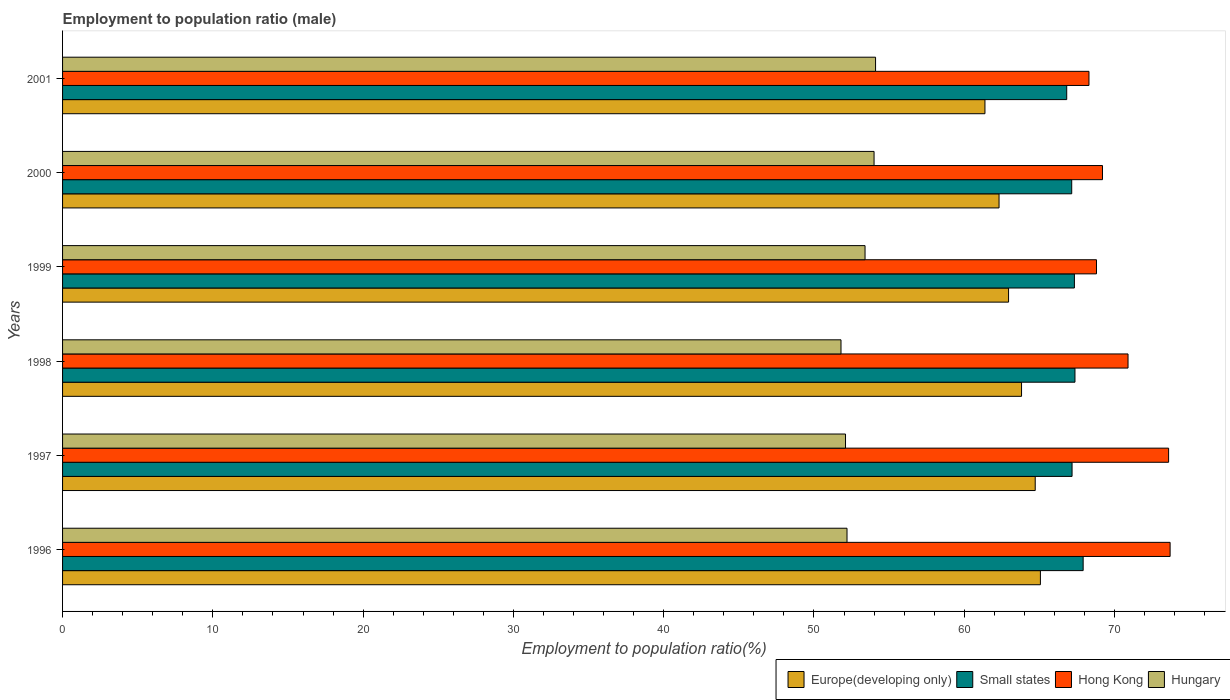How many different coloured bars are there?
Your answer should be very brief. 4. Are the number of bars per tick equal to the number of legend labels?
Offer a terse response. Yes. How many bars are there on the 6th tick from the bottom?
Offer a terse response. 4. What is the label of the 1st group of bars from the top?
Ensure brevity in your answer.  2001. In how many cases, is the number of bars for a given year not equal to the number of legend labels?
Offer a terse response. 0. What is the employment to population ratio in Hungary in 1998?
Offer a very short reply. 51.8. Across all years, what is the maximum employment to population ratio in Hungary?
Offer a terse response. 54.1. Across all years, what is the minimum employment to population ratio in Hong Kong?
Provide a short and direct response. 68.3. In which year was the employment to population ratio in Europe(developing only) maximum?
Keep it short and to the point. 1996. What is the total employment to population ratio in Small states in the graph?
Your answer should be compact. 403.76. What is the difference between the employment to population ratio in Small states in 1998 and that in 2000?
Keep it short and to the point. 0.22. What is the difference between the employment to population ratio in Hungary in 2000 and the employment to population ratio in Small states in 1998?
Your answer should be very brief. -13.37. What is the average employment to population ratio in Small states per year?
Offer a very short reply. 67.29. In the year 1998, what is the difference between the employment to population ratio in Small states and employment to population ratio in Europe(developing only)?
Keep it short and to the point. 3.56. In how many years, is the employment to population ratio in Hong Kong greater than 8 %?
Keep it short and to the point. 6. What is the ratio of the employment to population ratio in Small states in 2000 to that in 2001?
Ensure brevity in your answer.  1. What is the difference between the highest and the second highest employment to population ratio in Hungary?
Ensure brevity in your answer.  0.1. What is the difference between the highest and the lowest employment to population ratio in Hungary?
Your answer should be very brief. 2.3. Is the sum of the employment to population ratio in Hungary in 1996 and 1999 greater than the maximum employment to population ratio in Hong Kong across all years?
Provide a short and direct response. Yes. What does the 1st bar from the top in 2001 represents?
Keep it short and to the point. Hungary. What does the 2nd bar from the bottom in 2001 represents?
Your answer should be very brief. Small states. How many bars are there?
Provide a succinct answer. 24. Are all the bars in the graph horizontal?
Your response must be concise. Yes. What is the difference between two consecutive major ticks on the X-axis?
Your answer should be very brief. 10. Does the graph contain grids?
Keep it short and to the point. No. How many legend labels are there?
Offer a terse response. 4. How are the legend labels stacked?
Keep it short and to the point. Horizontal. What is the title of the graph?
Give a very brief answer. Employment to population ratio (male). What is the label or title of the Y-axis?
Offer a terse response. Years. What is the Employment to population ratio(%) in Europe(developing only) in 1996?
Make the answer very short. 65.07. What is the Employment to population ratio(%) of Small states in 1996?
Make the answer very short. 67.91. What is the Employment to population ratio(%) of Hong Kong in 1996?
Make the answer very short. 73.7. What is the Employment to population ratio(%) of Hungary in 1996?
Your answer should be compact. 52.2. What is the Employment to population ratio(%) in Europe(developing only) in 1997?
Provide a succinct answer. 64.72. What is the Employment to population ratio(%) in Small states in 1997?
Keep it short and to the point. 67.17. What is the Employment to population ratio(%) in Hong Kong in 1997?
Provide a short and direct response. 73.6. What is the Employment to population ratio(%) of Hungary in 1997?
Your answer should be compact. 52.1. What is the Employment to population ratio(%) of Europe(developing only) in 1998?
Ensure brevity in your answer.  63.81. What is the Employment to population ratio(%) of Small states in 1998?
Ensure brevity in your answer.  67.37. What is the Employment to population ratio(%) in Hong Kong in 1998?
Your answer should be compact. 70.9. What is the Employment to population ratio(%) of Hungary in 1998?
Keep it short and to the point. 51.8. What is the Employment to population ratio(%) of Europe(developing only) in 1999?
Your answer should be very brief. 62.95. What is the Employment to population ratio(%) of Small states in 1999?
Make the answer very short. 67.33. What is the Employment to population ratio(%) of Hong Kong in 1999?
Ensure brevity in your answer.  68.8. What is the Employment to population ratio(%) in Hungary in 1999?
Your response must be concise. 53.4. What is the Employment to population ratio(%) in Europe(developing only) in 2000?
Your response must be concise. 62.32. What is the Employment to population ratio(%) in Small states in 2000?
Your answer should be very brief. 67.15. What is the Employment to population ratio(%) in Hong Kong in 2000?
Make the answer very short. 69.2. What is the Employment to population ratio(%) of Hungary in 2000?
Ensure brevity in your answer.  54. What is the Employment to population ratio(%) in Europe(developing only) in 2001?
Provide a succinct answer. 61.38. What is the Employment to population ratio(%) in Small states in 2001?
Ensure brevity in your answer.  66.82. What is the Employment to population ratio(%) in Hong Kong in 2001?
Ensure brevity in your answer.  68.3. What is the Employment to population ratio(%) in Hungary in 2001?
Provide a short and direct response. 54.1. Across all years, what is the maximum Employment to population ratio(%) of Europe(developing only)?
Offer a very short reply. 65.07. Across all years, what is the maximum Employment to population ratio(%) in Small states?
Ensure brevity in your answer.  67.91. Across all years, what is the maximum Employment to population ratio(%) in Hong Kong?
Your response must be concise. 73.7. Across all years, what is the maximum Employment to population ratio(%) of Hungary?
Your answer should be compact. 54.1. Across all years, what is the minimum Employment to population ratio(%) in Europe(developing only)?
Keep it short and to the point. 61.38. Across all years, what is the minimum Employment to population ratio(%) of Small states?
Ensure brevity in your answer.  66.82. Across all years, what is the minimum Employment to population ratio(%) in Hong Kong?
Offer a very short reply. 68.3. Across all years, what is the minimum Employment to population ratio(%) in Hungary?
Give a very brief answer. 51.8. What is the total Employment to population ratio(%) in Europe(developing only) in the graph?
Ensure brevity in your answer.  380.25. What is the total Employment to population ratio(%) in Small states in the graph?
Provide a short and direct response. 403.76. What is the total Employment to population ratio(%) in Hong Kong in the graph?
Make the answer very short. 424.5. What is the total Employment to population ratio(%) in Hungary in the graph?
Offer a terse response. 317.6. What is the difference between the Employment to population ratio(%) of Europe(developing only) in 1996 and that in 1997?
Provide a succinct answer. 0.35. What is the difference between the Employment to population ratio(%) in Small states in 1996 and that in 1997?
Your answer should be compact. 0.74. What is the difference between the Employment to population ratio(%) of Europe(developing only) in 1996 and that in 1998?
Offer a terse response. 1.26. What is the difference between the Employment to population ratio(%) of Small states in 1996 and that in 1998?
Keep it short and to the point. 0.54. What is the difference between the Employment to population ratio(%) of Hungary in 1996 and that in 1998?
Give a very brief answer. 0.4. What is the difference between the Employment to population ratio(%) of Europe(developing only) in 1996 and that in 1999?
Keep it short and to the point. 2.12. What is the difference between the Employment to population ratio(%) in Small states in 1996 and that in 1999?
Offer a terse response. 0.58. What is the difference between the Employment to population ratio(%) in Europe(developing only) in 1996 and that in 2000?
Offer a very short reply. 2.75. What is the difference between the Employment to population ratio(%) in Small states in 1996 and that in 2000?
Make the answer very short. 0.76. What is the difference between the Employment to population ratio(%) in Hong Kong in 1996 and that in 2000?
Your answer should be very brief. 4.5. What is the difference between the Employment to population ratio(%) in Hungary in 1996 and that in 2000?
Your answer should be very brief. -1.8. What is the difference between the Employment to population ratio(%) of Europe(developing only) in 1996 and that in 2001?
Offer a very short reply. 3.69. What is the difference between the Employment to population ratio(%) in Small states in 1996 and that in 2001?
Offer a very short reply. 1.09. What is the difference between the Employment to population ratio(%) of Europe(developing only) in 1997 and that in 1998?
Provide a succinct answer. 0.91. What is the difference between the Employment to population ratio(%) in Small states in 1997 and that in 1998?
Provide a succinct answer. -0.19. What is the difference between the Employment to population ratio(%) in Hong Kong in 1997 and that in 1998?
Keep it short and to the point. 2.7. What is the difference between the Employment to population ratio(%) of Hungary in 1997 and that in 1998?
Give a very brief answer. 0.3. What is the difference between the Employment to population ratio(%) of Europe(developing only) in 1997 and that in 1999?
Offer a very short reply. 1.77. What is the difference between the Employment to population ratio(%) in Small states in 1997 and that in 1999?
Provide a short and direct response. -0.16. What is the difference between the Employment to population ratio(%) of Hungary in 1997 and that in 1999?
Ensure brevity in your answer.  -1.3. What is the difference between the Employment to population ratio(%) of Europe(developing only) in 1997 and that in 2000?
Your response must be concise. 2.41. What is the difference between the Employment to population ratio(%) in Small states in 1997 and that in 2000?
Provide a short and direct response. 0.02. What is the difference between the Employment to population ratio(%) in Hungary in 1997 and that in 2000?
Ensure brevity in your answer.  -1.9. What is the difference between the Employment to population ratio(%) in Europe(developing only) in 1997 and that in 2001?
Keep it short and to the point. 3.34. What is the difference between the Employment to population ratio(%) in Small states in 1997 and that in 2001?
Provide a short and direct response. 0.36. What is the difference between the Employment to population ratio(%) in Hong Kong in 1997 and that in 2001?
Ensure brevity in your answer.  5.3. What is the difference between the Employment to population ratio(%) in Europe(developing only) in 1998 and that in 1999?
Make the answer very short. 0.86. What is the difference between the Employment to population ratio(%) in Small states in 1998 and that in 1999?
Give a very brief answer. 0.04. What is the difference between the Employment to population ratio(%) of Hong Kong in 1998 and that in 1999?
Ensure brevity in your answer.  2.1. What is the difference between the Employment to population ratio(%) in Europe(developing only) in 1998 and that in 2000?
Your answer should be very brief. 1.5. What is the difference between the Employment to population ratio(%) in Small states in 1998 and that in 2000?
Your response must be concise. 0.22. What is the difference between the Employment to population ratio(%) in Hong Kong in 1998 and that in 2000?
Ensure brevity in your answer.  1.7. What is the difference between the Employment to population ratio(%) in Europe(developing only) in 1998 and that in 2001?
Your answer should be compact. 2.43. What is the difference between the Employment to population ratio(%) in Small states in 1998 and that in 2001?
Your response must be concise. 0.55. What is the difference between the Employment to population ratio(%) of Hong Kong in 1998 and that in 2001?
Your response must be concise. 2.6. What is the difference between the Employment to population ratio(%) of Hungary in 1998 and that in 2001?
Your answer should be very brief. -2.3. What is the difference between the Employment to population ratio(%) of Europe(developing only) in 1999 and that in 2000?
Keep it short and to the point. 0.63. What is the difference between the Employment to population ratio(%) of Small states in 1999 and that in 2000?
Keep it short and to the point. 0.18. What is the difference between the Employment to population ratio(%) in Hong Kong in 1999 and that in 2000?
Your answer should be very brief. -0.4. What is the difference between the Employment to population ratio(%) of Hungary in 1999 and that in 2000?
Your response must be concise. -0.6. What is the difference between the Employment to population ratio(%) in Europe(developing only) in 1999 and that in 2001?
Provide a short and direct response. 1.57. What is the difference between the Employment to population ratio(%) in Small states in 1999 and that in 2001?
Provide a succinct answer. 0.51. What is the difference between the Employment to population ratio(%) of Hong Kong in 1999 and that in 2001?
Give a very brief answer. 0.5. What is the difference between the Employment to population ratio(%) in Europe(developing only) in 2000 and that in 2001?
Your response must be concise. 0.94. What is the difference between the Employment to population ratio(%) of Small states in 2000 and that in 2001?
Provide a short and direct response. 0.33. What is the difference between the Employment to population ratio(%) in Hungary in 2000 and that in 2001?
Your answer should be compact. -0.1. What is the difference between the Employment to population ratio(%) in Europe(developing only) in 1996 and the Employment to population ratio(%) in Small states in 1997?
Make the answer very short. -2.11. What is the difference between the Employment to population ratio(%) in Europe(developing only) in 1996 and the Employment to population ratio(%) in Hong Kong in 1997?
Give a very brief answer. -8.53. What is the difference between the Employment to population ratio(%) in Europe(developing only) in 1996 and the Employment to population ratio(%) in Hungary in 1997?
Give a very brief answer. 12.97. What is the difference between the Employment to population ratio(%) in Small states in 1996 and the Employment to population ratio(%) in Hong Kong in 1997?
Provide a succinct answer. -5.69. What is the difference between the Employment to population ratio(%) in Small states in 1996 and the Employment to population ratio(%) in Hungary in 1997?
Offer a very short reply. 15.81. What is the difference between the Employment to population ratio(%) in Hong Kong in 1996 and the Employment to population ratio(%) in Hungary in 1997?
Keep it short and to the point. 21.6. What is the difference between the Employment to population ratio(%) of Europe(developing only) in 1996 and the Employment to population ratio(%) of Small states in 1998?
Offer a terse response. -2.3. What is the difference between the Employment to population ratio(%) in Europe(developing only) in 1996 and the Employment to population ratio(%) in Hong Kong in 1998?
Keep it short and to the point. -5.83. What is the difference between the Employment to population ratio(%) of Europe(developing only) in 1996 and the Employment to population ratio(%) of Hungary in 1998?
Provide a succinct answer. 13.27. What is the difference between the Employment to population ratio(%) in Small states in 1996 and the Employment to population ratio(%) in Hong Kong in 1998?
Your response must be concise. -2.99. What is the difference between the Employment to population ratio(%) of Small states in 1996 and the Employment to population ratio(%) of Hungary in 1998?
Provide a short and direct response. 16.11. What is the difference between the Employment to population ratio(%) of Hong Kong in 1996 and the Employment to population ratio(%) of Hungary in 1998?
Offer a very short reply. 21.9. What is the difference between the Employment to population ratio(%) of Europe(developing only) in 1996 and the Employment to population ratio(%) of Small states in 1999?
Keep it short and to the point. -2.26. What is the difference between the Employment to population ratio(%) of Europe(developing only) in 1996 and the Employment to population ratio(%) of Hong Kong in 1999?
Provide a succinct answer. -3.73. What is the difference between the Employment to population ratio(%) of Europe(developing only) in 1996 and the Employment to population ratio(%) of Hungary in 1999?
Offer a very short reply. 11.67. What is the difference between the Employment to population ratio(%) in Small states in 1996 and the Employment to population ratio(%) in Hong Kong in 1999?
Your answer should be compact. -0.89. What is the difference between the Employment to population ratio(%) of Small states in 1996 and the Employment to population ratio(%) of Hungary in 1999?
Make the answer very short. 14.51. What is the difference between the Employment to population ratio(%) of Hong Kong in 1996 and the Employment to population ratio(%) of Hungary in 1999?
Give a very brief answer. 20.3. What is the difference between the Employment to population ratio(%) of Europe(developing only) in 1996 and the Employment to population ratio(%) of Small states in 2000?
Give a very brief answer. -2.08. What is the difference between the Employment to population ratio(%) in Europe(developing only) in 1996 and the Employment to population ratio(%) in Hong Kong in 2000?
Your response must be concise. -4.13. What is the difference between the Employment to population ratio(%) of Europe(developing only) in 1996 and the Employment to population ratio(%) of Hungary in 2000?
Give a very brief answer. 11.07. What is the difference between the Employment to population ratio(%) in Small states in 1996 and the Employment to population ratio(%) in Hong Kong in 2000?
Provide a succinct answer. -1.29. What is the difference between the Employment to population ratio(%) in Small states in 1996 and the Employment to population ratio(%) in Hungary in 2000?
Make the answer very short. 13.91. What is the difference between the Employment to population ratio(%) of Hong Kong in 1996 and the Employment to population ratio(%) of Hungary in 2000?
Offer a very short reply. 19.7. What is the difference between the Employment to population ratio(%) in Europe(developing only) in 1996 and the Employment to population ratio(%) in Small states in 2001?
Offer a terse response. -1.75. What is the difference between the Employment to population ratio(%) in Europe(developing only) in 1996 and the Employment to population ratio(%) in Hong Kong in 2001?
Give a very brief answer. -3.23. What is the difference between the Employment to population ratio(%) of Europe(developing only) in 1996 and the Employment to population ratio(%) of Hungary in 2001?
Your response must be concise. 10.97. What is the difference between the Employment to population ratio(%) of Small states in 1996 and the Employment to population ratio(%) of Hong Kong in 2001?
Offer a terse response. -0.39. What is the difference between the Employment to population ratio(%) in Small states in 1996 and the Employment to population ratio(%) in Hungary in 2001?
Your answer should be compact. 13.81. What is the difference between the Employment to population ratio(%) of Hong Kong in 1996 and the Employment to population ratio(%) of Hungary in 2001?
Make the answer very short. 19.6. What is the difference between the Employment to population ratio(%) in Europe(developing only) in 1997 and the Employment to population ratio(%) in Small states in 1998?
Provide a short and direct response. -2.65. What is the difference between the Employment to population ratio(%) of Europe(developing only) in 1997 and the Employment to population ratio(%) of Hong Kong in 1998?
Offer a very short reply. -6.18. What is the difference between the Employment to population ratio(%) of Europe(developing only) in 1997 and the Employment to population ratio(%) of Hungary in 1998?
Your response must be concise. 12.92. What is the difference between the Employment to population ratio(%) in Small states in 1997 and the Employment to population ratio(%) in Hong Kong in 1998?
Ensure brevity in your answer.  -3.73. What is the difference between the Employment to population ratio(%) in Small states in 1997 and the Employment to population ratio(%) in Hungary in 1998?
Provide a succinct answer. 15.38. What is the difference between the Employment to population ratio(%) in Hong Kong in 1997 and the Employment to population ratio(%) in Hungary in 1998?
Your answer should be very brief. 21.8. What is the difference between the Employment to population ratio(%) of Europe(developing only) in 1997 and the Employment to population ratio(%) of Small states in 1999?
Make the answer very short. -2.61. What is the difference between the Employment to population ratio(%) of Europe(developing only) in 1997 and the Employment to population ratio(%) of Hong Kong in 1999?
Offer a terse response. -4.08. What is the difference between the Employment to population ratio(%) of Europe(developing only) in 1997 and the Employment to population ratio(%) of Hungary in 1999?
Offer a very short reply. 11.32. What is the difference between the Employment to population ratio(%) of Small states in 1997 and the Employment to population ratio(%) of Hong Kong in 1999?
Offer a very short reply. -1.62. What is the difference between the Employment to population ratio(%) in Small states in 1997 and the Employment to population ratio(%) in Hungary in 1999?
Offer a very short reply. 13.78. What is the difference between the Employment to population ratio(%) in Hong Kong in 1997 and the Employment to population ratio(%) in Hungary in 1999?
Your response must be concise. 20.2. What is the difference between the Employment to population ratio(%) in Europe(developing only) in 1997 and the Employment to population ratio(%) in Small states in 2000?
Keep it short and to the point. -2.43. What is the difference between the Employment to population ratio(%) in Europe(developing only) in 1997 and the Employment to population ratio(%) in Hong Kong in 2000?
Make the answer very short. -4.48. What is the difference between the Employment to population ratio(%) of Europe(developing only) in 1997 and the Employment to population ratio(%) of Hungary in 2000?
Provide a succinct answer. 10.72. What is the difference between the Employment to population ratio(%) of Small states in 1997 and the Employment to population ratio(%) of Hong Kong in 2000?
Make the answer very short. -2.02. What is the difference between the Employment to population ratio(%) in Small states in 1997 and the Employment to population ratio(%) in Hungary in 2000?
Offer a very short reply. 13.18. What is the difference between the Employment to population ratio(%) of Hong Kong in 1997 and the Employment to population ratio(%) of Hungary in 2000?
Your response must be concise. 19.6. What is the difference between the Employment to population ratio(%) in Europe(developing only) in 1997 and the Employment to population ratio(%) in Small states in 2001?
Ensure brevity in your answer.  -2.1. What is the difference between the Employment to population ratio(%) in Europe(developing only) in 1997 and the Employment to population ratio(%) in Hong Kong in 2001?
Your answer should be compact. -3.58. What is the difference between the Employment to population ratio(%) of Europe(developing only) in 1997 and the Employment to population ratio(%) of Hungary in 2001?
Give a very brief answer. 10.62. What is the difference between the Employment to population ratio(%) in Small states in 1997 and the Employment to population ratio(%) in Hong Kong in 2001?
Provide a short and direct response. -1.12. What is the difference between the Employment to population ratio(%) in Small states in 1997 and the Employment to population ratio(%) in Hungary in 2001?
Keep it short and to the point. 13.07. What is the difference between the Employment to population ratio(%) in Hong Kong in 1997 and the Employment to population ratio(%) in Hungary in 2001?
Make the answer very short. 19.5. What is the difference between the Employment to population ratio(%) in Europe(developing only) in 1998 and the Employment to population ratio(%) in Small states in 1999?
Offer a very short reply. -3.52. What is the difference between the Employment to population ratio(%) in Europe(developing only) in 1998 and the Employment to population ratio(%) in Hong Kong in 1999?
Offer a terse response. -4.99. What is the difference between the Employment to population ratio(%) in Europe(developing only) in 1998 and the Employment to population ratio(%) in Hungary in 1999?
Your response must be concise. 10.41. What is the difference between the Employment to population ratio(%) of Small states in 1998 and the Employment to population ratio(%) of Hong Kong in 1999?
Provide a succinct answer. -1.43. What is the difference between the Employment to population ratio(%) of Small states in 1998 and the Employment to population ratio(%) of Hungary in 1999?
Make the answer very short. 13.97. What is the difference between the Employment to population ratio(%) in Hong Kong in 1998 and the Employment to population ratio(%) in Hungary in 1999?
Offer a very short reply. 17.5. What is the difference between the Employment to population ratio(%) in Europe(developing only) in 1998 and the Employment to population ratio(%) in Small states in 2000?
Keep it short and to the point. -3.34. What is the difference between the Employment to population ratio(%) of Europe(developing only) in 1998 and the Employment to population ratio(%) of Hong Kong in 2000?
Make the answer very short. -5.39. What is the difference between the Employment to population ratio(%) in Europe(developing only) in 1998 and the Employment to population ratio(%) in Hungary in 2000?
Provide a short and direct response. 9.81. What is the difference between the Employment to population ratio(%) of Small states in 1998 and the Employment to population ratio(%) of Hong Kong in 2000?
Your answer should be very brief. -1.83. What is the difference between the Employment to population ratio(%) of Small states in 1998 and the Employment to population ratio(%) of Hungary in 2000?
Ensure brevity in your answer.  13.37. What is the difference between the Employment to population ratio(%) in Europe(developing only) in 1998 and the Employment to population ratio(%) in Small states in 2001?
Offer a very short reply. -3.01. What is the difference between the Employment to population ratio(%) of Europe(developing only) in 1998 and the Employment to population ratio(%) of Hong Kong in 2001?
Offer a very short reply. -4.49. What is the difference between the Employment to population ratio(%) in Europe(developing only) in 1998 and the Employment to population ratio(%) in Hungary in 2001?
Your response must be concise. 9.71. What is the difference between the Employment to population ratio(%) of Small states in 1998 and the Employment to population ratio(%) of Hong Kong in 2001?
Make the answer very short. -0.93. What is the difference between the Employment to population ratio(%) in Small states in 1998 and the Employment to population ratio(%) in Hungary in 2001?
Ensure brevity in your answer.  13.27. What is the difference between the Employment to population ratio(%) of Hong Kong in 1998 and the Employment to population ratio(%) of Hungary in 2001?
Your response must be concise. 16.8. What is the difference between the Employment to population ratio(%) of Europe(developing only) in 1999 and the Employment to population ratio(%) of Small states in 2000?
Offer a terse response. -4.2. What is the difference between the Employment to population ratio(%) of Europe(developing only) in 1999 and the Employment to population ratio(%) of Hong Kong in 2000?
Offer a very short reply. -6.25. What is the difference between the Employment to population ratio(%) of Europe(developing only) in 1999 and the Employment to population ratio(%) of Hungary in 2000?
Provide a short and direct response. 8.95. What is the difference between the Employment to population ratio(%) in Small states in 1999 and the Employment to population ratio(%) in Hong Kong in 2000?
Ensure brevity in your answer.  -1.87. What is the difference between the Employment to population ratio(%) of Small states in 1999 and the Employment to population ratio(%) of Hungary in 2000?
Offer a very short reply. 13.33. What is the difference between the Employment to population ratio(%) in Europe(developing only) in 1999 and the Employment to population ratio(%) in Small states in 2001?
Your answer should be very brief. -3.87. What is the difference between the Employment to population ratio(%) in Europe(developing only) in 1999 and the Employment to population ratio(%) in Hong Kong in 2001?
Your answer should be compact. -5.35. What is the difference between the Employment to population ratio(%) of Europe(developing only) in 1999 and the Employment to population ratio(%) of Hungary in 2001?
Keep it short and to the point. 8.85. What is the difference between the Employment to population ratio(%) in Small states in 1999 and the Employment to population ratio(%) in Hong Kong in 2001?
Ensure brevity in your answer.  -0.97. What is the difference between the Employment to population ratio(%) of Small states in 1999 and the Employment to population ratio(%) of Hungary in 2001?
Keep it short and to the point. 13.23. What is the difference between the Employment to population ratio(%) of Hong Kong in 1999 and the Employment to population ratio(%) of Hungary in 2001?
Offer a terse response. 14.7. What is the difference between the Employment to population ratio(%) in Europe(developing only) in 2000 and the Employment to population ratio(%) in Small states in 2001?
Make the answer very short. -4.5. What is the difference between the Employment to population ratio(%) in Europe(developing only) in 2000 and the Employment to population ratio(%) in Hong Kong in 2001?
Your response must be concise. -5.98. What is the difference between the Employment to population ratio(%) of Europe(developing only) in 2000 and the Employment to population ratio(%) of Hungary in 2001?
Give a very brief answer. 8.22. What is the difference between the Employment to population ratio(%) in Small states in 2000 and the Employment to population ratio(%) in Hong Kong in 2001?
Your answer should be compact. -1.15. What is the difference between the Employment to population ratio(%) of Small states in 2000 and the Employment to population ratio(%) of Hungary in 2001?
Offer a very short reply. 13.05. What is the difference between the Employment to population ratio(%) of Hong Kong in 2000 and the Employment to population ratio(%) of Hungary in 2001?
Your response must be concise. 15.1. What is the average Employment to population ratio(%) in Europe(developing only) per year?
Ensure brevity in your answer.  63.38. What is the average Employment to population ratio(%) of Small states per year?
Offer a terse response. 67.29. What is the average Employment to population ratio(%) of Hong Kong per year?
Your answer should be compact. 70.75. What is the average Employment to population ratio(%) of Hungary per year?
Your answer should be very brief. 52.93. In the year 1996, what is the difference between the Employment to population ratio(%) in Europe(developing only) and Employment to population ratio(%) in Small states?
Your answer should be very brief. -2.84. In the year 1996, what is the difference between the Employment to population ratio(%) of Europe(developing only) and Employment to population ratio(%) of Hong Kong?
Offer a terse response. -8.63. In the year 1996, what is the difference between the Employment to population ratio(%) of Europe(developing only) and Employment to population ratio(%) of Hungary?
Make the answer very short. 12.87. In the year 1996, what is the difference between the Employment to population ratio(%) in Small states and Employment to population ratio(%) in Hong Kong?
Offer a terse response. -5.79. In the year 1996, what is the difference between the Employment to population ratio(%) in Small states and Employment to population ratio(%) in Hungary?
Ensure brevity in your answer.  15.71. In the year 1997, what is the difference between the Employment to population ratio(%) of Europe(developing only) and Employment to population ratio(%) of Small states?
Your answer should be compact. -2.45. In the year 1997, what is the difference between the Employment to population ratio(%) in Europe(developing only) and Employment to population ratio(%) in Hong Kong?
Provide a succinct answer. -8.88. In the year 1997, what is the difference between the Employment to population ratio(%) in Europe(developing only) and Employment to population ratio(%) in Hungary?
Provide a succinct answer. 12.62. In the year 1997, what is the difference between the Employment to population ratio(%) of Small states and Employment to population ratio(%) of Hong Kong?
Provide a succinct answer. -6.42. In the year 1997, what is the difference between the Employment to population ratio(%) of Small states and Employment to population ratio(%) of Hungary?
Your answer should be very brief. 15.07. In the year 1998, what is the difference between the Employment to population ratio(%) in Europe(developing only) and Employment to population ratio(%) in Small states?
Offer a very short reply. -3.56. In the year 1998, what is the difference between the Employment to population ratio(%) of Europe(developing only) and Employment to population ratio(%) of Hong Kong?
Your answer should be very brief. -7.09. In the year 1998, what is the difference between the Employment to population ratio(%) in Europe(developing only) and Employment to population ratio(%) in Hungary?
Give a very brief answer. 12.01. In the year 1998, what is the difference between the Employment to population ratio(%) of Small states and Employment to population ratio(%) of Hong Kong?
Provide a succinct answer. -3.53. In the year 1998, what is the difference between the Employment to population ratio(%) in Small states and Employment to population ratio(%) in Hungary?
Provide a succinct answer. 15.57. In the year 1999, what is the difference between the Employment to population ratio(%) of Europe(developing only) and Employment to population ratio(%) of Small states?
Ensure brevity in your answer.  -4.38. In the year 1999, what is the difference between the Employment to population ratio(%) of Europe(developing only) and Employment to population ratio(%) of Hong Kong?
Make the answer very short. -5.85. In the year 1999, what is the difference between the Employment to population ratio(%) in Europe(developing only) and Employment to population ratio(%) in Hungary?
Your answer should be compact. 9.55. In the year 1999, what is the difference between the Employment to population ratio(%) in Small states and Employment to population ratio(%) in Hong Kong?
Your response must be concise. -1.47. In the year 1999, what is the difference between the Employment to population ratio(%) in Small states and Employment to population ratio(%) in Hungary?
Ensure brevity in your answer.  13.93. In the year 1999, what is the difference between the Employment to population ratio(%) in Hong Kong and Employment to population ratio(%) in Hungary?
Your answer should be very brief. 15.4. In the year 2000, what is the difference between the Employment to population ratio(%) in Europe(developing only) and Employment to population ratio(%) in Small states?
Your answer should be compact. -4.84. In the year 2000, what is the difference between the Employment to population ratio(%) in Europe(developing only) and Employment to population ratio(%) in Hong Kong?
Provide a short and direct response. -6.88. In the year 2000, what is the difference between the Employment to population ratio(%) in Europe(developing only) and Employment to population ratio(%) in Hungary?
Make the answer very short. 8.32. In the year 2000, what is the difference between the Employment to population ratio(%) of Small states and Employment to population ratio(%) of Hong Kong?
Your answer should be compact. -2.05. In the year 2000, what is the difference between the Employment to population ratio(%) of Small states and Employment to population ratio(%) of Hungary?
Ensure brevity in your answer.  13.15. In the year 2001, what is the difference between the Employment to population ratio(%) of Europe(developing only) and Employment to population ratio(%) of Small states?
Give a very brief answer. -5.44. In the year 2001, what is the difference between the Employment to population ratio(%) in Europe(developing only) and Employment to population ratio(%) in Hong Kong?
Your answer should be very brief. -6.92. In the year 2001, what is the difference between the Employment to population ratio(%) of Europe(developing only) and Employment to population ratio(%) of Hungary?
Keep it short and to the point. 7.28. In the year 2001, what is the difference between the Employment to population ratio(%) of Small states and Employment to population ratio(%) of Hong Kong?
Your answer should be very brief. -1.48. In the year 2001, what is the difference between the Employment to population ratio(%) in Small states and Employment to population ratio(%) in Hungary?
Make the answer very short. 12.72. In the year 2001, what is the difference between the Employment to population ratio(%) of Hong Kong and Employment to population ratio(%) of Hungary?
Your answer should be very brief. 14.2. What is the ratio of the Employment to population ratio(%) in Europe(developing only) in 1996 to that in 1998?
Offer a very short reply. 1.02. What is the ratio of the Employment to population ratio(%) in Hong Kong in 1996 to that in 1998?
Your answer should be compact. 1.04. What is the ratio of the Employment to population ratio(%) of Hungary in 1996 to that in 1998?
Your answer should be very brief. 1.01. What is the ratio of the Employment to population ratio(%) of Europe(developing only) in 1996 to that in 1999?
Keep it short and to the point. 1.03. What is the ratio of the Employment to population ratio(%) of Small states in 1996 to that in 1999?
Offer a very short reply. 1.01. What is the ratio of the Employment to population ratio(%) in Hong Kong in 1996 to that in 1999?
Your response must be concise. 1.07. What is the ratio of the Employment to population ratio(%) in Hungary in 1996 to that in 1999?
Offer a terse response. 0.98. What is the ratio of the Employment to population ratio(%) of Europe(developing only) in 1996 to that in 2000?
Offer a very short reply. 1.04. What is the ratio of the Employment to population ratio(%) of Small states in 1996 to that in 2000?
Keep it short and to the point. 1.01. What is the ratio of the Employment to population ratio(%) of Hong Kong in 1996 to that in 2000?
Your answer should be compact. 1.06. What is the ratio of the Employment to population ratio(%) in Hungary in 1996 to that in 2000?
Make the answer very short. 0.97. What is the ratio of the Employment to population ratio(%) in Europe(developing only) in 1996 to that in 2001?
Give a very brief answer. 1.06. What is the ratio of the Employment to population ratio(%) in Small states in 1996 to that in 2001?
Your answer should be compact. 1.02. What is the ratio of the Employment to population ratio(%) of Hong Kong in 1996 to that in 2001?
Your response must be concise. 1.08. What is the ratio of the Employment to population ratio(%) in Hungary in 1996 to that in 2001?
Make the answer very short. 0.96. What is the ratio of the Employment to population ratio(%) of Europe(developing only) in 1997 to that in 1998?
Make the answer very short. 1.01. What is the ratio of the Employment to population ratio(%) of Small states in 1997 to that in 1998?
Ensure brevity in your answer.  1. What is the ratio of the Employment to population ratio(%) in Hong Kong in 1997 to that in 1998?
Offer a terse response. 1.04. What is the ratio of the Employment to population ratio(%) of Europe(developing only) in 1997 to that in 1999?
Offer a very short reply. 1.03. What is the ratio of the Employment to population ratio(%) of Hong Kong in 1997 to that in 1999?
Ensure brevity in your answer.  1.07. What is the ratio of the Employment to population ratio(%) of Hungary in 1997 to that in 1999?
Your answer should be compact. 0.98. What is the ratio of the Employment to population ratio(%) in Europe(developing only) in 1997 to that in 2000?
Offer a terse response. 1.04. What is the ratio of the Employment to population ratio(%) of Hong Kong in 1997 to that in 2000?
Your answer should be very brief. 1.06. What is the ratio of the Employment to population ratio(%) in Hungary in 1997 to that in 2000?
Keep it short and to the point. 0.96. What is the ratio of the Employment to population ratio(%) of Europe(developing only) in 1997 to that in 2001?
Your answer should be compact. 1.05. What is the ratio of the Employment to population ratio(%) of Small states in 1997 to that in 2001?
Your answer should be very brief. 1.01. What is the ratio of the Employment to population ratio(%) in Hong Kong in 1997 to that in 2001?
Provide a short and direct response. 1.08. What is the ratio of the Employment to population ratio(%) in Europe(developing only) in 1998 to that in 1999?
Offer a terse response. 1.01. What is the ratio of the Employment to population ratio(%) in Hong Kong in 1998 to that in 1999?
Give a very brief answer. 1.03. What is the ratio of the Employment to population ratio(%) of Hungary in 1998 to that in 1999?
Make the answer very short. 0.97. What is the ratio of the Employment to population ratio(%) in Small states in 1998 to that in 2000?
Your answer should be compact. 1. What is the ratio of the Employment to population ratio(%) of Hong Kong in 1998 to that in 2000?
Make the answer very short. 1.02. What is the ratio of the Employment to population ratio(%) in Hungary in 1998 to that in 2000?
Your response must be concise. 0.96. What is the ratio of the Employment to population ratio(%) in Europe(developing only) in 1998 to that in 2001?
Provide a succinct answer. 1.04. What is the ratio of the Employment to population ratio(%) of Small states in 1998 to that in 2001?
Your response must be concise. 1.01. What is the ratio of the Employment to population ratio(%) in Hong Kong in 1998 to that in 2001?
Provide a succinct answer. 1.04. What is the ratio of the Employment to population ratio(%) in Hungary in 1998 to that in 2001?
Offer a terse response. 0.96. What is the ratio of the Employment to population ratio(%) in Europe(developing only) in 1999 to that in 2000?
Provide a succinct answer. 1.01. What is the ratio of the Employment to population ratio(%) in Small states in 1999 to that in 2000?
Your answer should be very brief. 1. What is the ratio of the Employment to population ratio(%) of Hungary in 1999 to that in 2000?
Your answer should be very brief. 0.99. What is the ratio of the Employment to population ratio(%) of Europe(developing only) in 1999 to that in 2001?
Your answer should be very brief. 1.03. What is the ratio of the Employment to population ratio(%) in Small states in 1999 to that in 2001?
Make the answer very short. 1.01. What is the ratio of the Employment to population ratio(%) of Hong Kong in 1999 to that in 2001?
Give a very brief answer. 1.01. What is the ratio of the Employment to population ratio(%) in Hungary in 1999 to that in 2001?
Provide a succinct answer. 0.99. What is the ratio of the Employment to population ratio(%) in Europe(developing only) in 2000 to that in 2001?
Your answer should be very brief. 1.02. What is the ratio of the Employment to population ratio(%) in Small states in 2000 to that in 2001?
Give a very brief answer. 1. What is the ratio of the Employment to population ratio(%) in Hong Kong in 2000 to that in 2001?
Your answer should be very brief. 1.01. What is the ratio of the Employment to population ratio(%) of Hungary in 2000 to that in 2001?
Ensure brevity in your answer.  1. What is the difference between the highest and the second highest Employment to population ratio(%) in Europe(developing only)?
Provide a succinct answer. 0.35. What is the difference between the highest and the second highest Employment to population ratio(%) in Small states?
Offer a very short reply. 0.54. What is the difference between the highest and the second highest Employment to population ratio(%) in Hong Kong?
Provide a short and direct response. 0.1. What is the difference between the highest and the lowest Employment to population ratio(%) of Europe(developing only)?
Give a very brief answer. 3.69. What is the difference between the highest and the lowest Employment to population ratio(%) in Small states?
Your answer should be very brief. 1.09. What is the difference between the highest and the lowest Employment to population ratio(%) in Hungary?
Your answer should be compact. 2.3. 